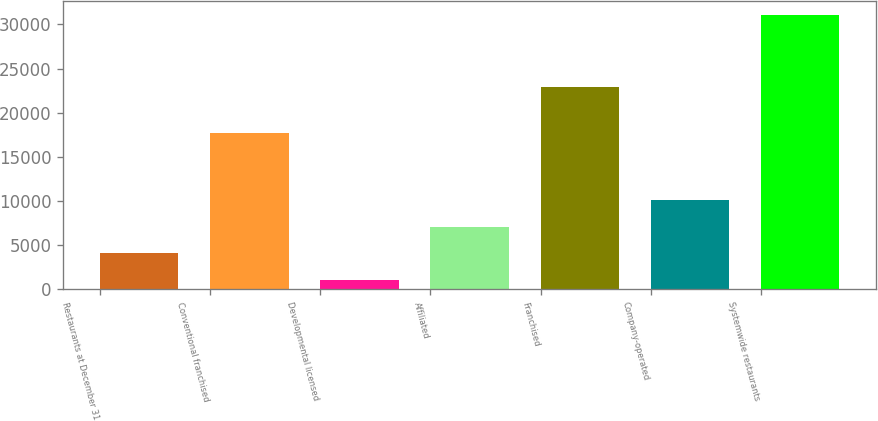Convert chart to OTSL. <chart><loc_0><loc_0><loc_500><loc_500><bar_chart><fcel>Restaurants at December 31<fcel>Conventional franchised<fcel>Developmental licensed<fcel>Affiliated<fcel>Franchised<fcel>Company-operated<fcel>Systemwide restaurants<nl><fcel>4061.3<fcel>17683<fcel>1063<fcel>7059.6<fcel>22880<fcel>10057.9<fcel>31046<nl></chart> 